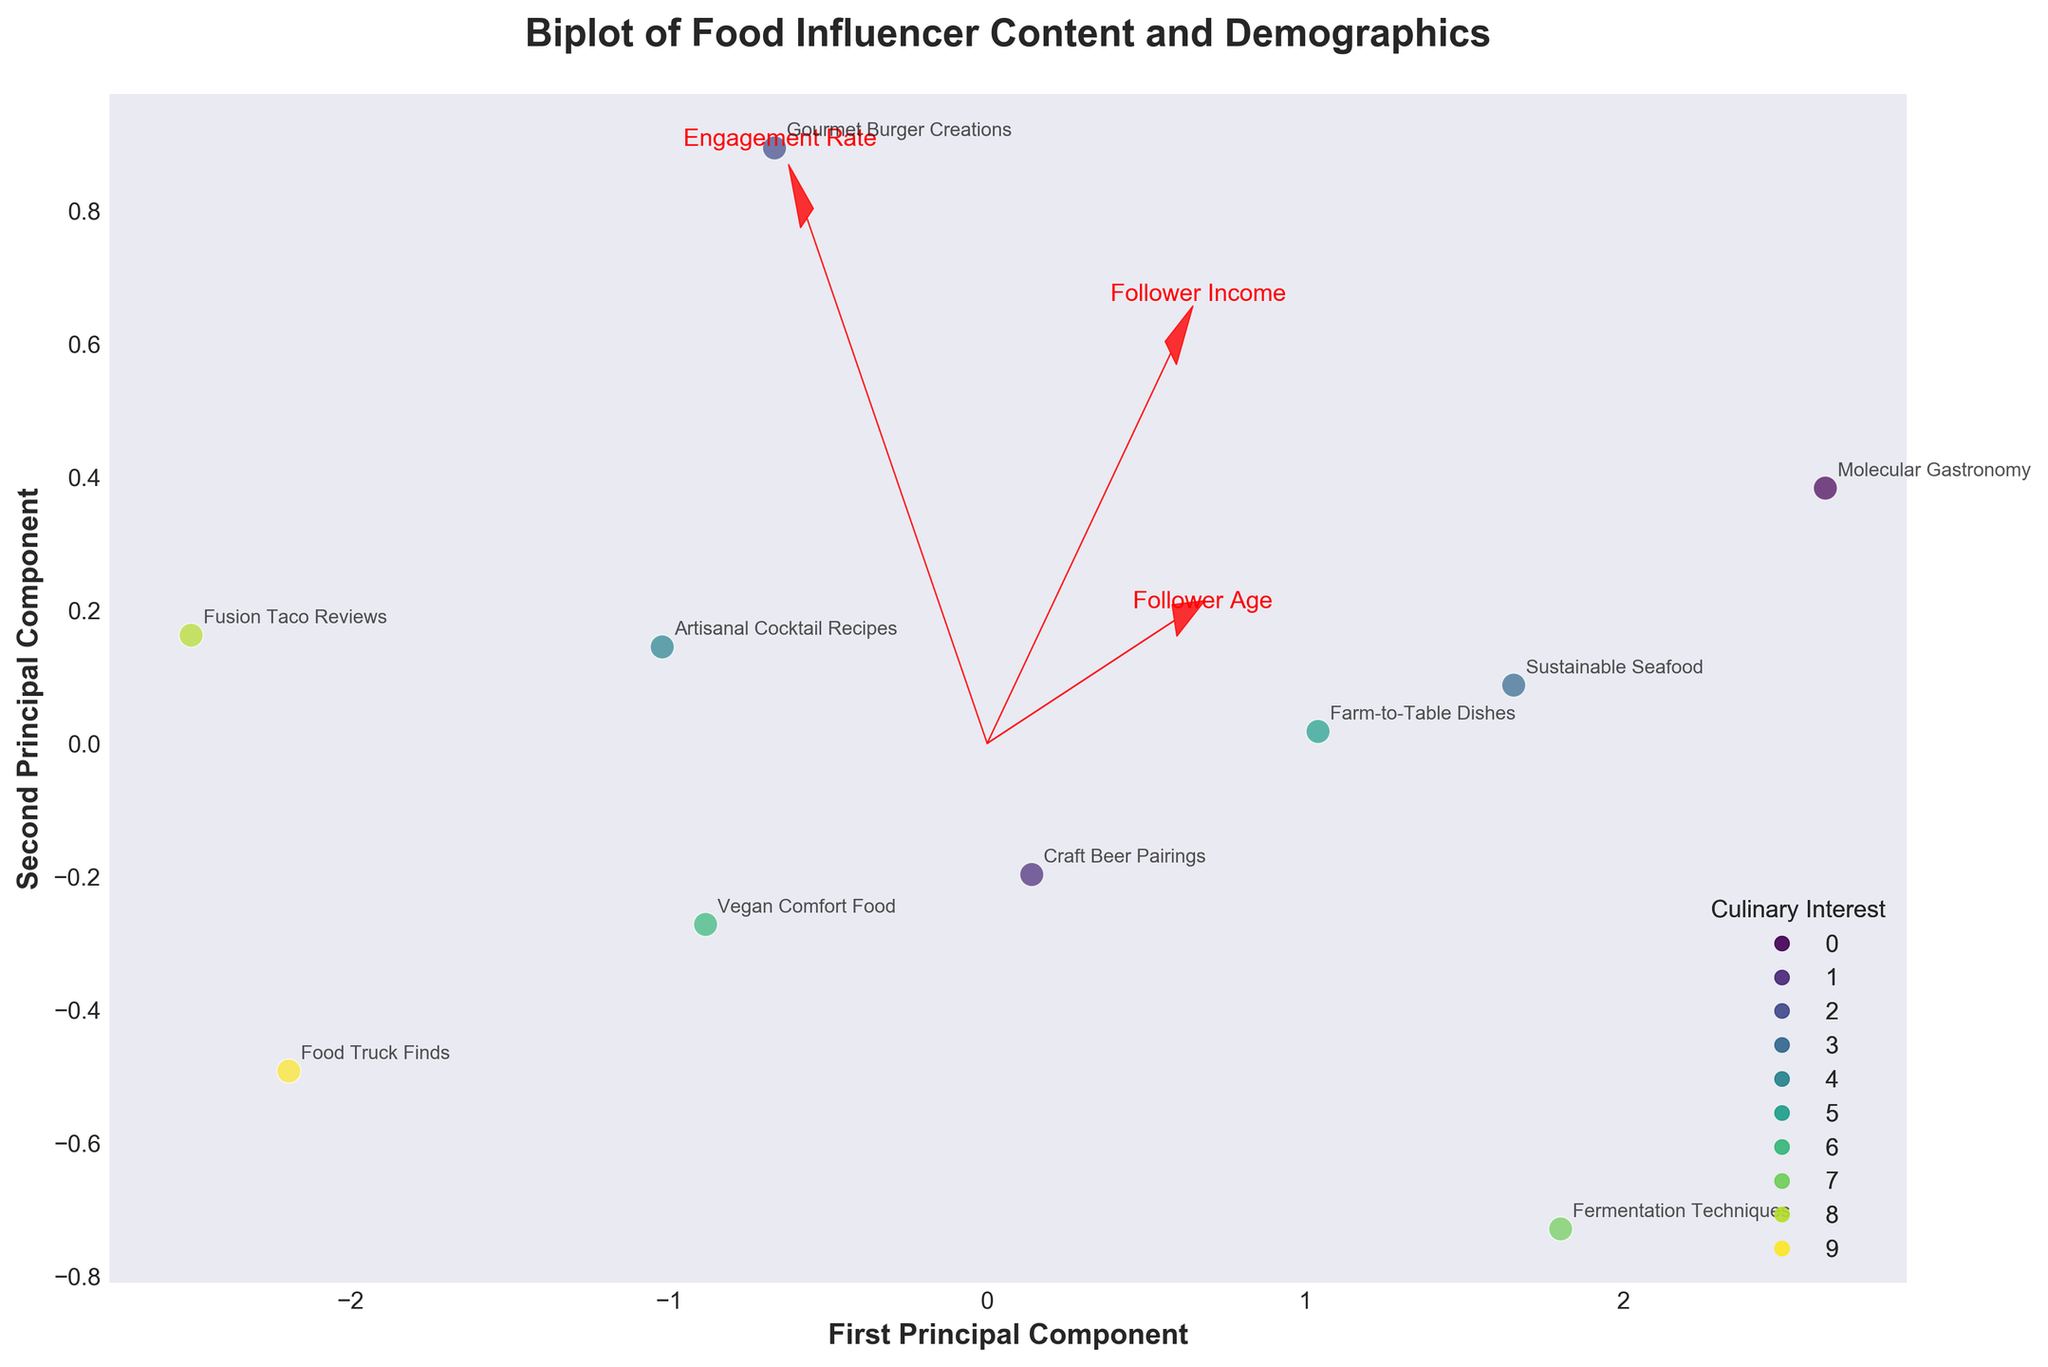What's the title of the figure? The title is prominently displayed at the top of the figure. In this case, it reads "Biplot of Food Influencer Content and Demographics."
Answer: Biplot of Food Influencer Content and Demographics How many data points are there in the plot? Each data point represents a different type of food influencer content. By counting the number of distinct markers or labels, we can see there are 10 data points.
Answer: 10 Which content type has the highest engagement rate? By observing the PCA-transformed coordinates, you can see that 'Fusion Taco Reviews' (Fusion Taco Reviews is at one of the outer positions indicating high Engagement Rate). Cross-referencing it with the dataset confirms 'Fusion Taco Reviews' with a corresponding high PCA coordinate demonstrates the highest engagement rate of 4.5.
Answer: Fusion Taco Reviews Which culinary interest is associated with artisanal cocktail recipes? The culinary interests are color-coded. Using the color of the data point for 'Artisanal Cocktail Recipes' and referring to the legend, the associated culinary interest is determined.
Answer: Mixology What feature arrow indicates the direction of increasing follower age? The features are represented by arrows. The arrow labeled 'Follower Age' shows the direction of increasing age, aligned with the axis pointing in the positive direction along PC1 or PC2.
Answer: Follower Age Are there any content types related to urban dining with an engagement rate higher than 4? We first identify the content types associated with 'Urban Dining', and then check their engagement rates. 'Food Truck Finds' associated with Urban Dining has an engagement rate above 4.
Answer: Yes Which two content types are closest to each other on the biplot? By looking at the scatter plot's clustering, 'Gourmet Burger Creations' and 'Craft Beer Pairings' are very close to each other. Their proximity suggests similar follower demographics and engagement rates.
Answer: Gourmet Burger Creations and Craft Beer Pairings Which content type appears to have a higher follower income: Molecular Gastronomy or Fermentation Techniques? By finding both points on the scatter plot and noting their relative positions in relation to the 'Follower Income' arrow, we can see 'Molecular Gastronomy' is nearer the high end, indicating higher follower income.
Answer: Molecular Gastronomy What is the relationship between engagement rate and follower age for Vegan Comfort Food based on the plot? We locate the Vegan Comfort Food point and consider its position relative to the 'Engagement Rate' and 'Follower Age' arrows. It's moderately high in engagement and approximately median in follower age.
Answer: Moderately high engagement, median follower age 